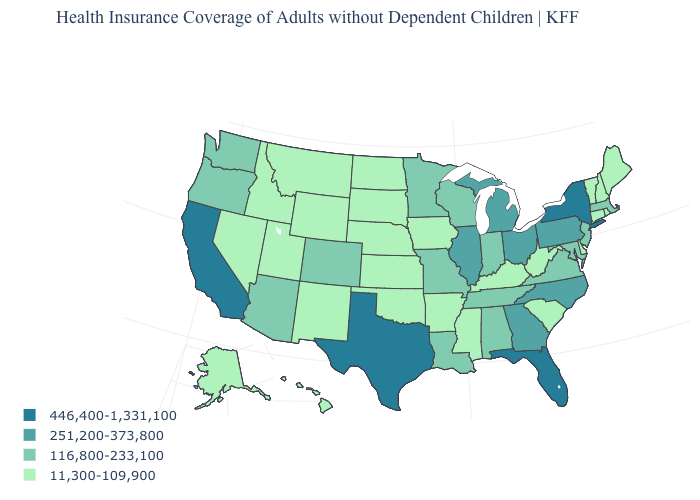How many symbols are there in the legend?
Write a very short answer. 4. Is the legend a continuous bar?
Short answer required. No. Which states have the lowest value in the MidWest?
Give a very brief answer. Iowa, Kansas, Nebraska, North Dakota, South Dakota. Which states have the highest value in the USA?
Answer briefly. California, Florida, New York, Texas. Among the states that border North Dakota , which have the lowest value?
Give a very brief answer. Montana, South Dakota. What is the value of Wyoming?
Keep it brief. 11,300-109,900. What is the value of Illinois?
Keep it brief. 251,200-373,800. What is the highest value in the South ?
Quick response, please. 446,400-1,331,100. What is the value of Utah?
Answer briefly. 11,300-109,900. Does the first symbol in the legend represent the smallest category?
Keep it brief. No. What is the highest value in states that border Arizona?
Keep it brief. 446,400-1,331,100. Is the legend a continuous bar?
Quick response, please. No. Name the states that have a value in the range 251,200-373,800?
Concise answer only. Georgia, Illinois, Michigan, North Carolina, Ohio, Pennsylvania. Name the states that have a value in the range 446,400-1,331,100?
Write a very short answer. California, Florida, New York, Texas. What is the lowest value in the USA?
Give a very brief answer. 11,300-109,900. 